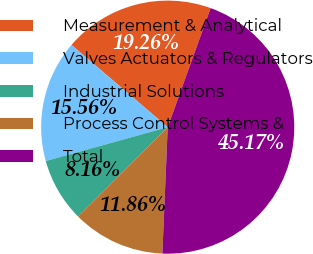Convert chart. <chart><loc_0><loc_0><loc_500><loc_500><pie_chart><fcel>Measurement & Analytical<fcel>Valves Actuators & Regulators<fcel>Industrial Solutions<fcel>Process Control Systems &<fcel>Total<nl><fcel>19.26%<fcel>15.56%<fcel>8.16%<fcel>11.86%<fcel>45.17%<nl></chart> 